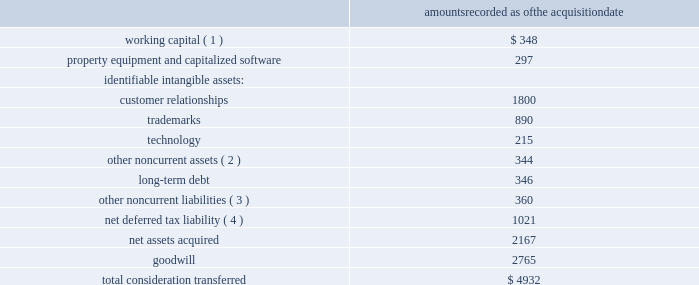And $ 19 million of these expenses in 2011 and 2010 , respectively , with the remaining expense unallocated .
The company financed the acquisition with the proceeds from a $ 1.0 billion three-year term loan credit facility , $ 1.5 billion in unsecured notes , and the issuance of 61 million shares of aon common stock .
In addition , as part of the consideration , certain outstanding hewitt stock options were converted into options to purchase 4.5 million shares of aon common stock .
These items are detailed further in note 8 2018 2018debt 2019 2019 and note 11 2018 2018stockholders 2019 equity 2019 2019 .
The transaction has been accounted for using the acquisition method of accounting which requires , among other things , that most assets acquired and liabilities assumed be recognized at their fair values as of the acquisition date .
The table summarizes the amounts recognized for assets acquired and liabilities assumed as of the acquisition date ( in millions ) : amounts recorded as of the acquisition .
( 1 ) includes cash and cash equivalents , short-term investments , client receivables , other current assets , accounts payable and other current liabilities .
( 2 ) includes primarily deferred contract costs and long-term investments .
( 3 ) includes primarily unfavorable lease obligations and deferred contract revenues .
( 4 ) included in other current assets ( $ 31 million ) , deferred tax assets ( $ 30 million ) , other current liabilities ( $ 7 million ) and deferred tax liabilities ( $ 1.1 billion ) in the company 2019s consolidated statements of financial position .
The acquired customer relationships are being amortized over a weighted average life of 12 years .
The technology asset is being amortized over 7 years and trademarks have been determined to have indefinite useful lives .
Goodwill is calculated as the excess of the acquisition cost over the fair value of the net assets acquired and represents the synergies and other benefits that are expected to arise from combining the operations of hewitt with the operations of aon , and the future economic benefits arising from other assets acquired that could not be individually identified and separately recognized .
Goodwill is not amortized and is not deductible for tax purposes .
A single estimate of fair value results from a complex series of the company 2019s judgments about future events and uncertainties and relies heavily on estimates and assumptions .
The company 2019s .
What is the total value of identified intangible assets? 
Computations: ((1800 + 890) + 215)
Answer: 2905.0. And $ 19 million of these expenses in 2011 and 2010 , respectively , with the remaining expense unallocated .
The company financed the acquisition with the proceeds from a $ 1.0 billion three-year term loan credit facility , $ 1.5 billion in unsecured notes , and the issuance of 61 million shares of aon common stock .
In addition , as part of the consideration , certain outstanding hewitt stock options were converted into options to purchase 4.5 million shares of aon common stock .
These items are detailed further in note 8 2018 2018debt 2019 2019 and note 11 2018 2018stockholders 2019 equity 2019 2019 .
The transaction has been accounted for using the acquisition method of accounting which requires , among other things , that most assets acquired and liabilities assumed be recognized at their fair values as of the acquisition date .
The table summarizes the amounts recognized for assets acquired and liabilities assumed as of the acquisition date ( in millions ) : amounts recorded as of the acquisition .
( 1 ) includes cash and cash equivalents , short-term investments , client receivables , other current assets , accounts payable and other current liabilities .
( 2 ) includes primarily deferred contract costs and long-term investments .
( 3 ) includes primarily unfavorable lease obligations and deferred contract revenues .
( 4 ) included in other current assets ( $ 31 million ) , deferred tax assets ( $ 30 million ) , other current liabilities ( $ 7 million ) and deferred tax liabilities ( $ 1.1 billion ) in the company 2019s consolidated statements of financial position .
The acquired customer relationships are being amortized over a weighted average life of 12 years .
The technology asset is being amortized over 7 years and trademarks have been determined to have indefinite useful lives .
Goodwill is calculated as the excess of the acquisition cost over the fair value of the net assets acquired and represents the synergies and other benefits that are expected to arise from combining the operations of hewitt with the operations of aon , and the future economic benefits arising from other assets acquired that could not be individually identified and separately recognized .
Goodwill is not amortized and is not deductible for tax purposes .
A single estimate of fair value results from a complex series of the company 2019s judgments about future events and uncertainties and relies heavily on estimates and assumptions .
The company 2019s .
What portion of the total consideration transferred is dedicated to goodwill? 
Computations: (2765 / 4932)
Answer: 0.56062. 